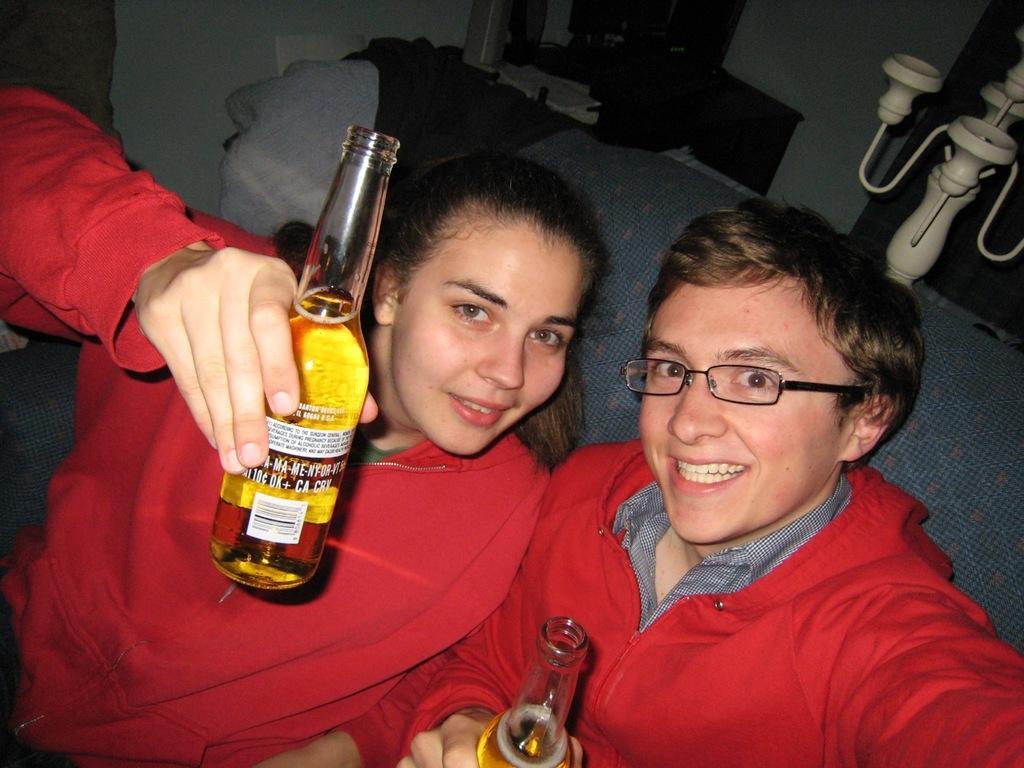Can you describe this image briefly? This picture is clicked inside a room. On the right corner of the picture, we see a man in black shirt is wearing red jacket. He is also wearing spectacles and he is laughing. He is catching a beer bottle in his hands. On the left corner of the picture, we see a woman wearing a red jacket is holding a beer bottle in her hands and she is also smiling and both of them are sitting in sofa. Behind the sofa, we see a wall. 